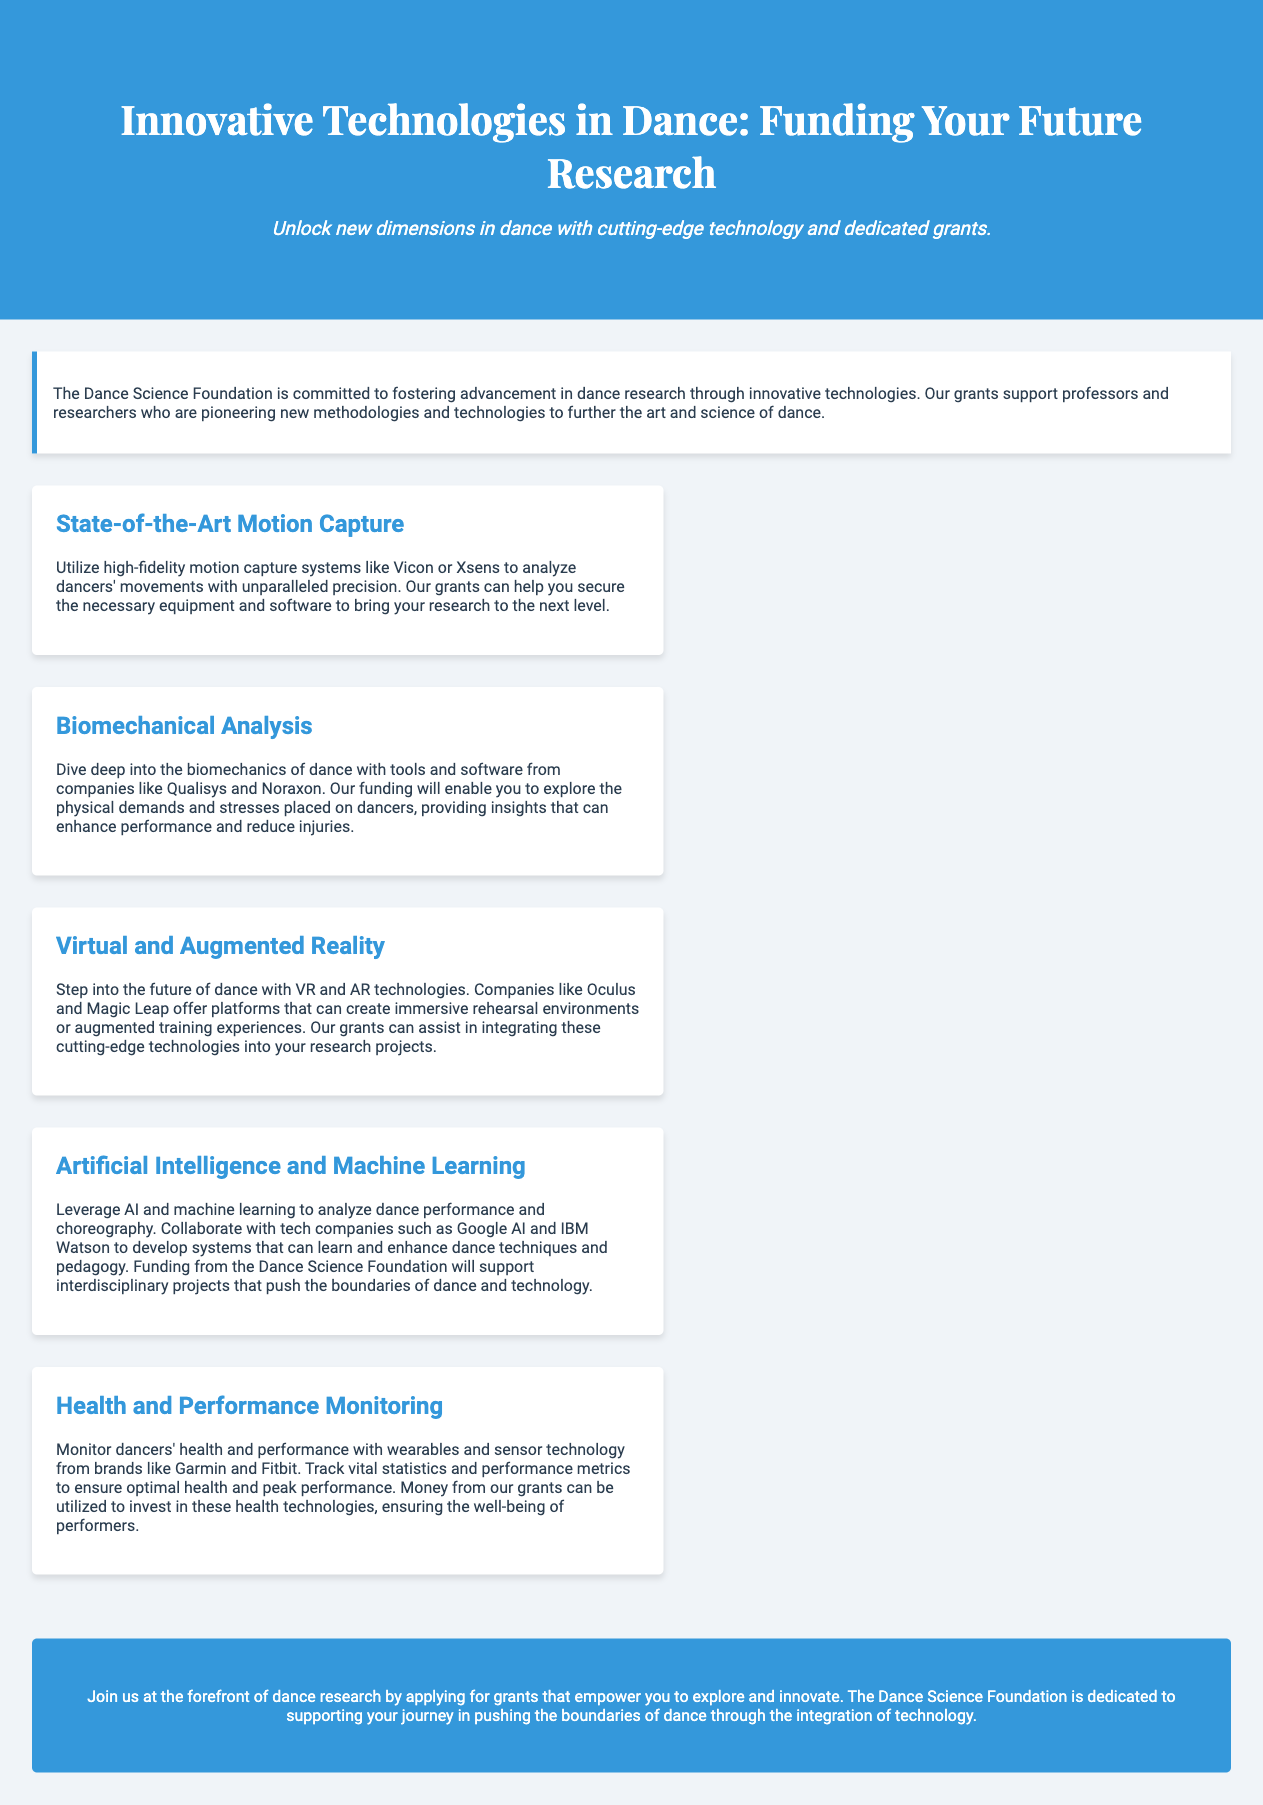What is the main purpose of the Dance Science Foundation? The document states that the purpose is to foster advancement in dance research through innovative technologies.
Answer: Advancement in dance research What technology is mentioned for motion capture? The document lists Vicon and Xsens as high-fidelity motion capture systems.
Answer: Vicon and Xsens Which companies provide tools for biomechanical analysis? The document mentions Qualisys and Noraxon as companies offering tools for this purpose.
Answer: Qualisys and Noraxon What technologies do Oculus and Magic Leap specialize in? The document indicates that Oculus and Magic Leap are associated with virtual and augmented reality.
Answer: Virtual and Augmented Reality What is the significance of wearables in dance research according to the document? The document explains that wearables monitor dancers' health and performance.
Answer: Health and performance monitoring How does the Dance Science Foundation support interdisciplinary projects? The document states that funding from the foundation supports AI and machine learning projects that push the boundaries of dance and technology.
Answer: By providing funding for AI and machine learning projects What type of grants does the Dance Science Foundation offer? The document indicates that the foundation offers grants for research in innovative technologies in dance.
Answer: Grants for research What is the concluding invitation of the document? The conclusion encourages applying for grants to explore and innovate in dance research.
Answer: Apply for grants 